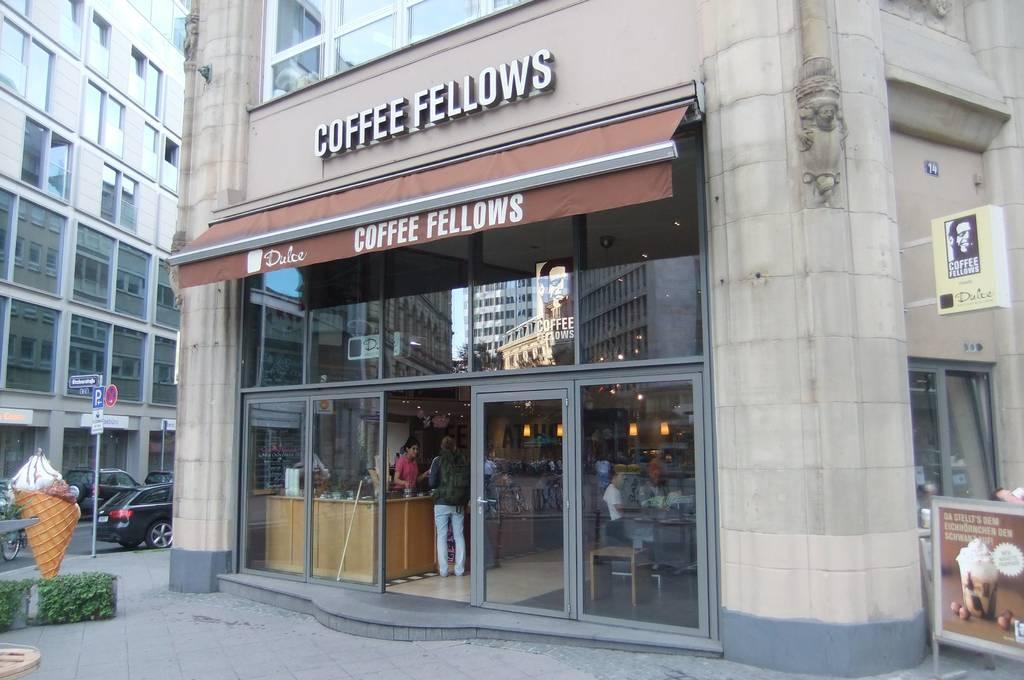Can you describe this image briefly? We can see buildings and there are people inside this building,beside this building we can see boards. We can see boards on pole,vehicles on the road and plants. 